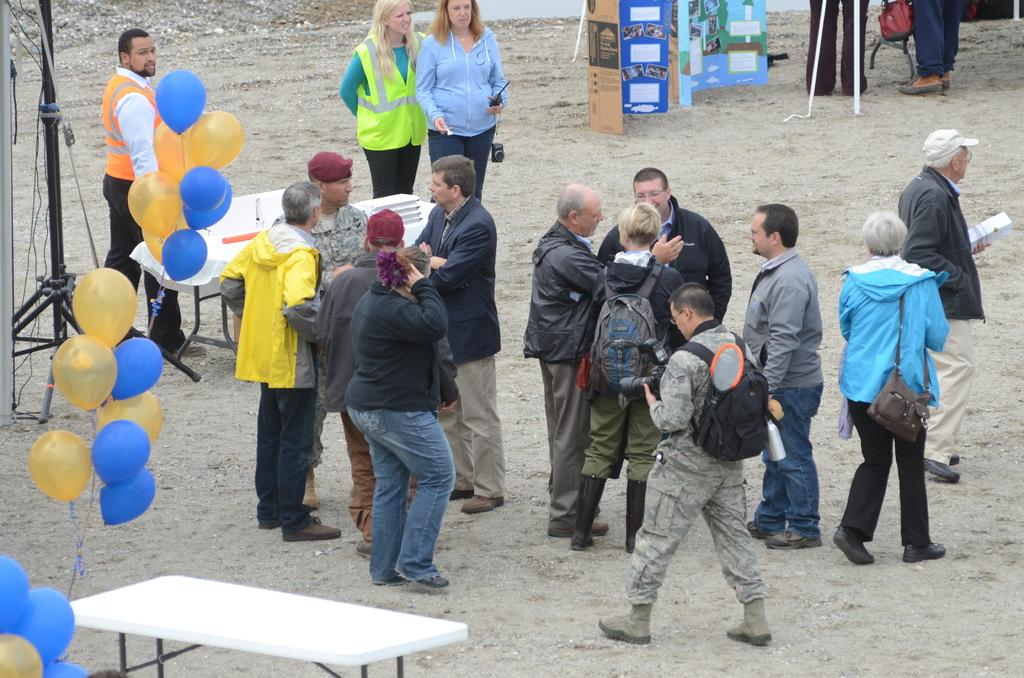What is happening with the group of people in the image? The people in the image are standing and talking with each other. What objects can be seen in the image besides the people? There is a camera stand, tables, and balloons in the image. What type of rhythm is being played by the van in the image? There is no van present in the image, so there is no rhythm being played. How many cherries are on top of the balloons in the image? There are no cherries present in the image; only balloons are mentioned. 